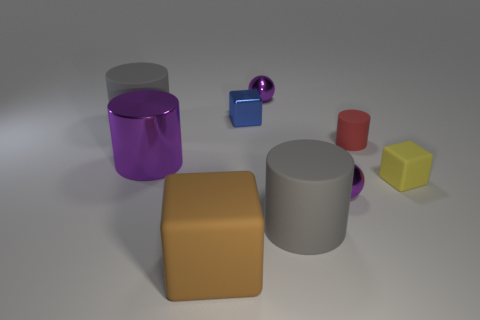Is there any other thing that has the same color as the big metal cylinder?
Offer a terse response. Yes. How many tiny metal objects are the same color as the large metallic thing?
Your response must be concise. 2. There is a tiny matte cylinder; how many big matte cylinders are in front of it?
Your answer should be compact. 1. What is the material of the blue block?
Provide a succinct answer. Metal. Are there fewer brown matte things behind the blue metallic block than tiny cyan shiny cylinders?
Ensure brevity in your answer.  No. What is the color of the large shiny object that is left of the yellow matte thing?
Give a very brief answer. Purple. What is the shape of the yellow rubber thing?
Your response must be concise. Cube. Is there a purple ball that is behind the small matte object behind the yellow rubber thing right of the tiny red rubber thing?
Provide a succinct answer. Yes. What is the color of the tiny object in front of the small block that is to the right of the gray rubber cylinder right of the tiny blue cube?
Your answer should be compact. Purple. There is a large object that is the same shape as the tiny yellow thing; what is it made of?
Your answer should be very brief. Rubber. 